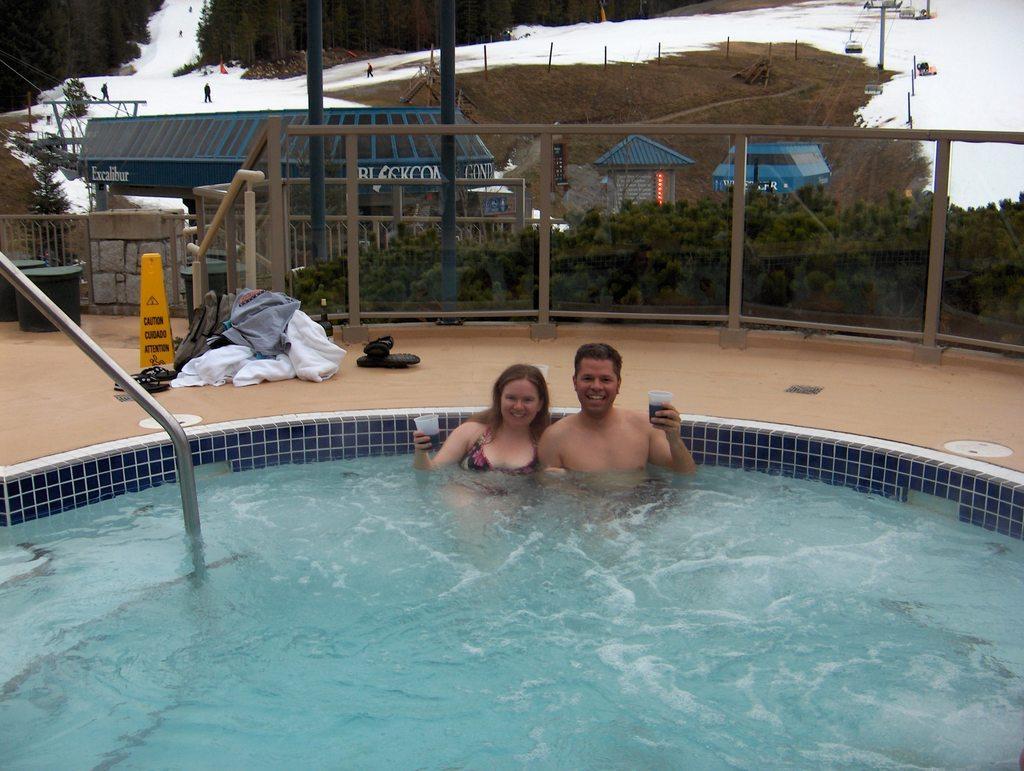In one or two sentences, can you explain what this image depicts? There is a woman and a man in swimming pool by holding a glass with liquid in it in their hand. In the background there are clothes,footwear and some other objects on the floor and we can also see fence,trees,houses,poles,cable cars on the right and few persons standing on the snow on the left. 